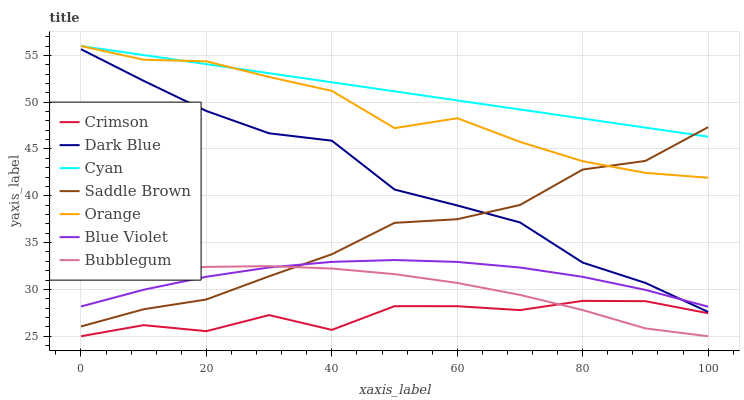Does Crimson have the minimum area under the curve?
Answer yes or no. Yes. Does Cyan have the maximum area under the curve?
Answer yes or no. Yes. Does Dark Blue have the minimum area under the curve?
Answer yes or no. No. Does Dark Blue have the maximum area under the curve?
Answer yes or no. No. Is Cyan the smoothest?
Answer yes or no. Yes. Is Crimson the roughest?
Answer yes or no. Yes. Is Dark Blue the smoothest?
Answer yes or no. No. Is Dark Blue the roughest?
Answer yes or no. No. Does Bubblegum have the lowest value?
Answer yes or no. Yes. Does Dark Blue have the lowest value?
Answer yes or no. No. Does Orange have the highest value?
Answer yes or no. Yes. Does Dark Blue have the highest value?
Answer yes or no. No. Is Crimson less than Saddle Brown?
Answer yes or no. Yes. Is Orange greater than Crimson?
Answer yes or no. Yes. Does Saddle Brown intersect Blue Violet?
Answer yes or no. Yes. Is Saddle Brown less than Blue Violet?
Answer yes or no. No. Is Saddle Brown greater than Blue Violet?
Answer yes or no. No. Does Crimson intersect Saddle Brown?
Answer yes or no. No. 